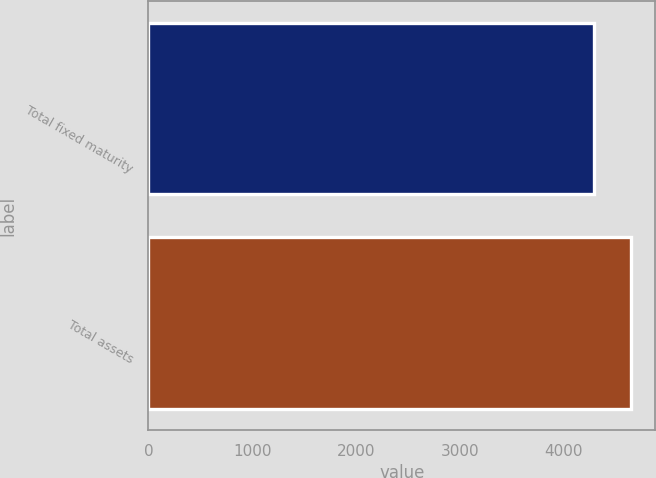Convert chart. <chart><loc_0><loc_0><loc_500><loc_500><bar_chart><fcel>Total fixed maturity<fcel>Total assets<nl><fcel>4291<fcel>4651<nl></chart> 